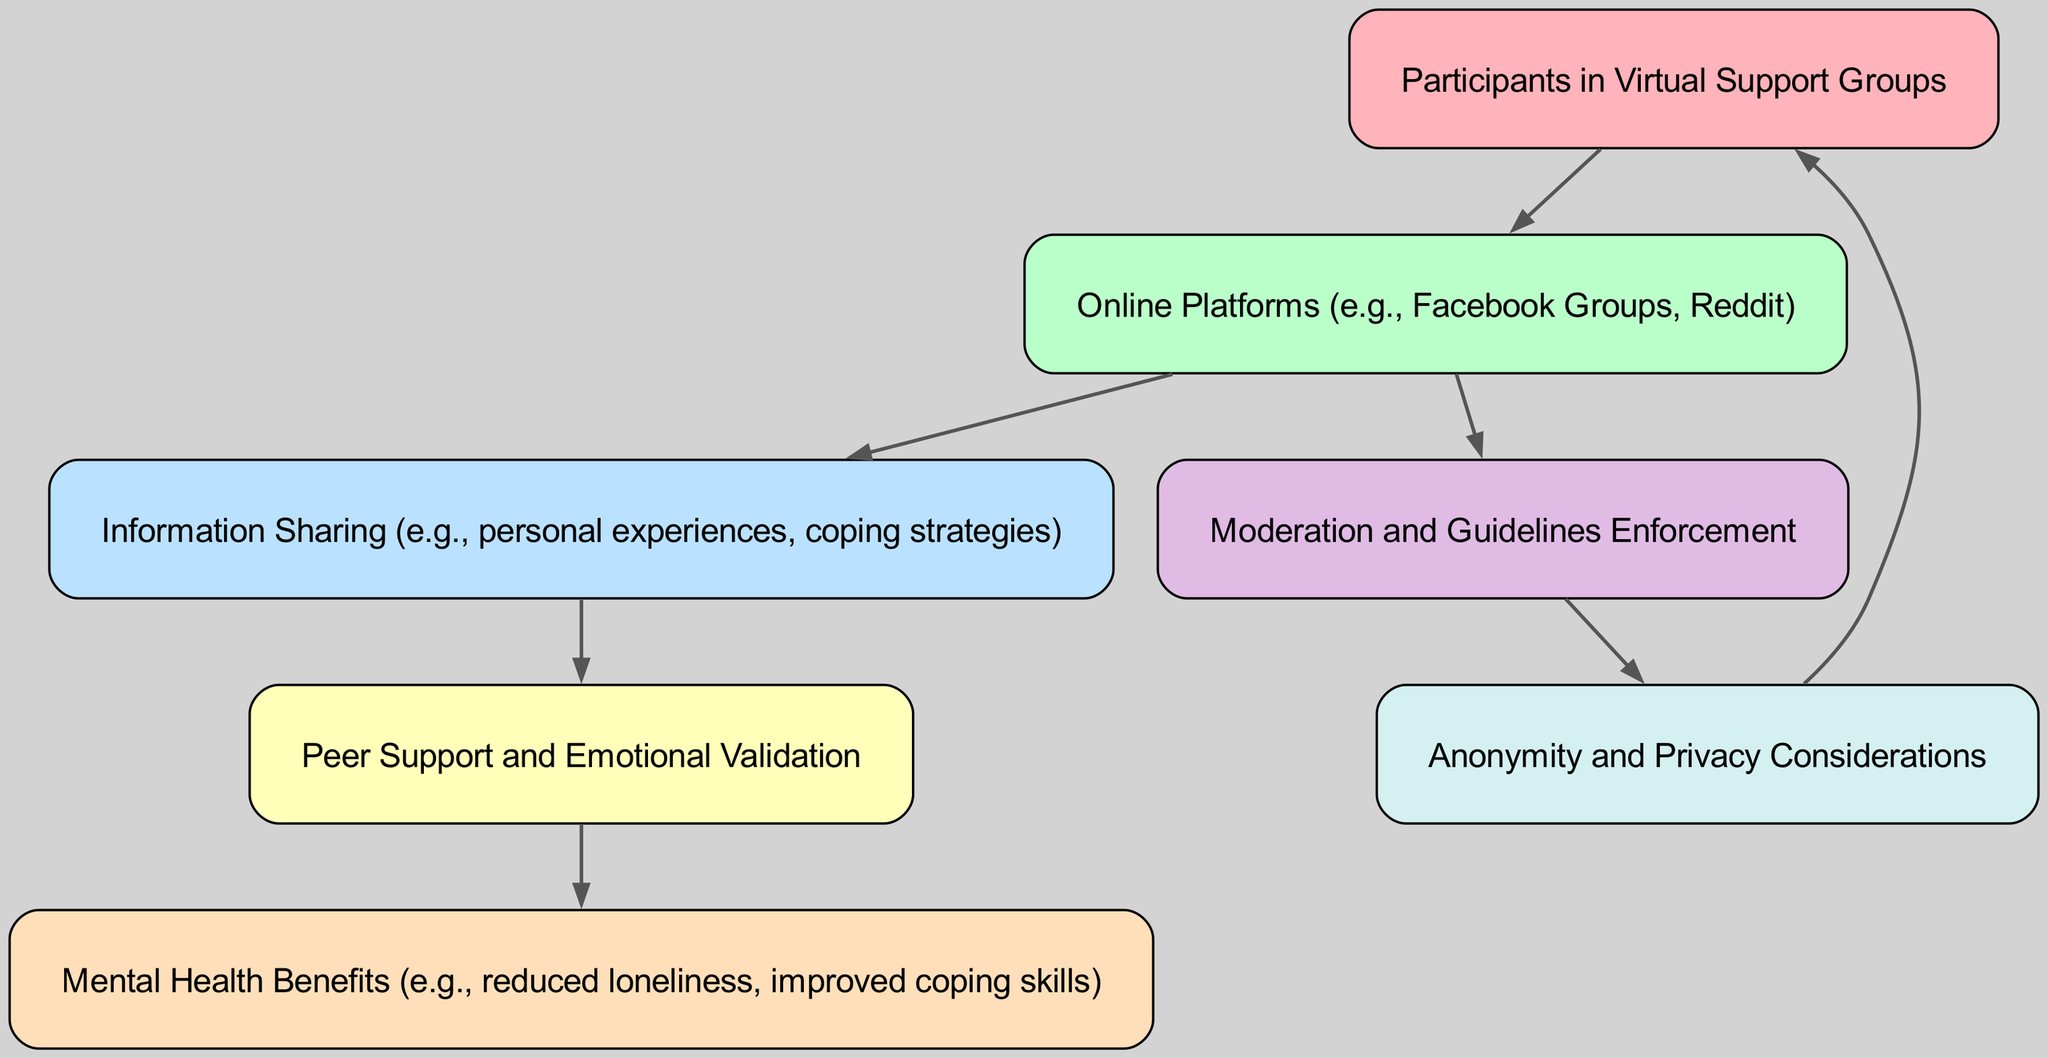what are the participants in the diagram? The diagram identifies "Participants in Virtual Support Groups" as the primary group of nodes, under the label "User".
Answer: Participants in Virtual Support Groups how many nodes are present in the diagram? By counting the distinct entries within the 'nodes' section, we find there are 7 unique nodes represented in the diagram.
Answer: 7 how many edges are connecting "User" to other nodes? The "User" node has one outgoing edge to the "Online Platforms" node based on the directed edges in the diagram.
Answer: 1 which node is the source for "Peer Support and Emotional Validation"? The directed flow reveals that "Information Sharing" is the node leading to "Peer Support," making it the source for that particular node.
Answer: Information Sharing what is the relationship between "Moderation" and "Anonymity"? The diagram shows a directional edge from "Moderation" to "Anonymity," indicating that moderation likely influences or enforces considerations of anonymity in the support environment.
Answer: Moderation influences Anonymity which node ultimately contributes to "Mental Health Benefits"? Following the flow from "Peer Support and Emotional Validation," the information culminates in "Mental Health Benefits," demonstrating a direct relationship.
Answer: Peer Support and Emotional Validation if "Online Platforms" were to be removed, what would be the impact on the flow of information? Removing "Online Platforms" would sever connections between "User" and "Information Sharing," obstructing the entire information flow that leads to mental health benefits.
Answer: Flow of information would be obstructed how does "Anonymity" loop back to "User"? The diagram illustrates a directed edge from "Anonymity" back to "User," suggesting that user privacy concerns can be influenced by or influence participants' experience in virtual support groups.
Answer: Privacy concerns influence users 